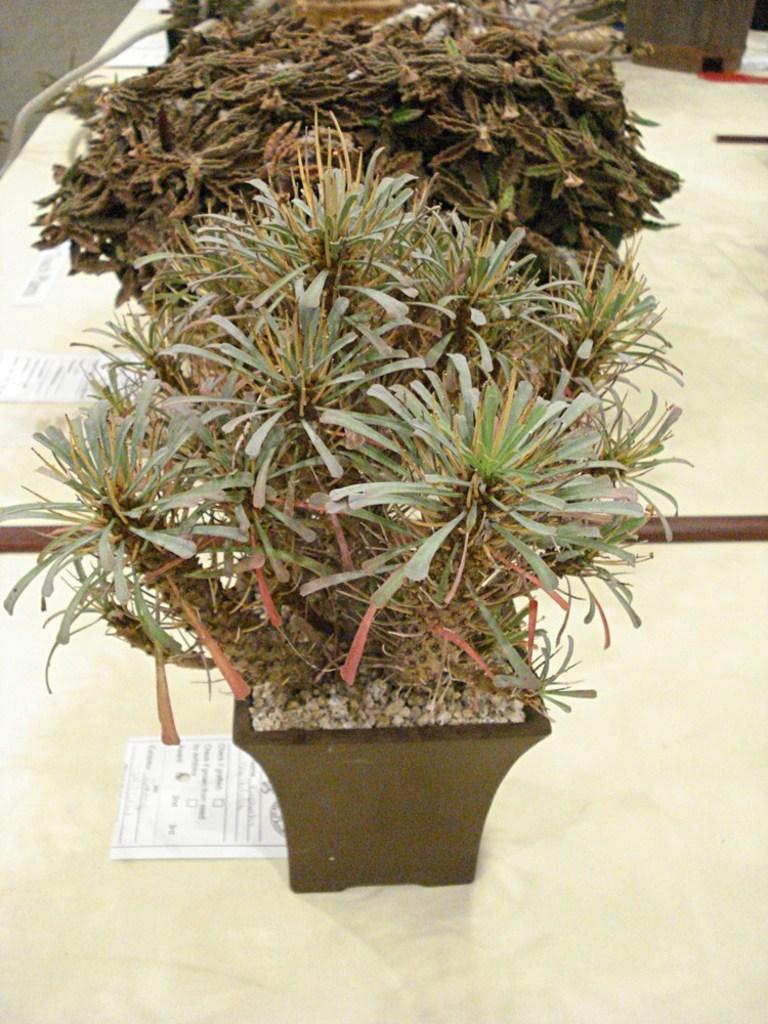In one or two sentences, can you explain what this image depicts? In this image, there are a few plants. Among them, we can see a plant in a pot. We can see some stones. There are a few tables with objects like posters with text. 